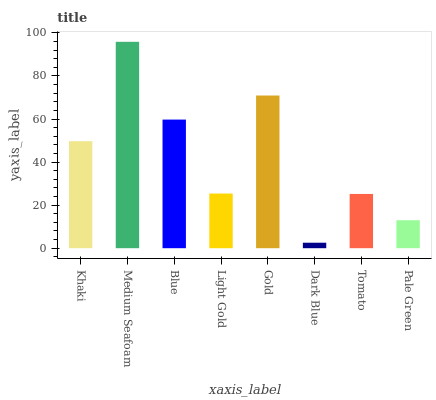Is Blue the minimum?
Answer yes or no. No. Is Blue the maximum?
Answer yes or no. No. Is Medium Seafoam greater than Blue?
Answer yes or no. Yes. Is Blue less than Medium Seafoam?
Answer yes or no. Yes. Is Blue greater than Medium Seafoam?
Answer yes or no. No. Is Medium Seafoam less than Blue?
Answer yes or no. No. Is Khaki the high median?
Answer yes or no. Yes. Is Light Gold the low median?
Answer yes or no. Yes. Is Gold the high median?
Answer yes or no. No. Is Pale Green the low median?
Answer yes or no. No. 